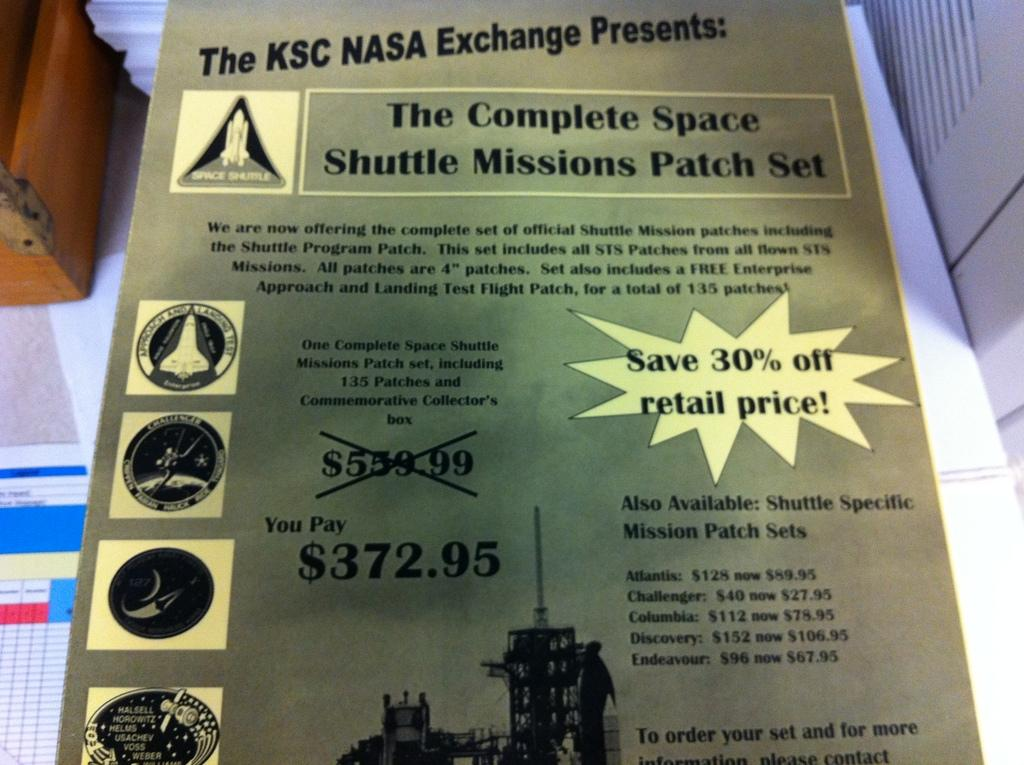<image>
Render a clear and concise summary of the photo. A complete space shuttle mission patch set is sold for $372.95. 